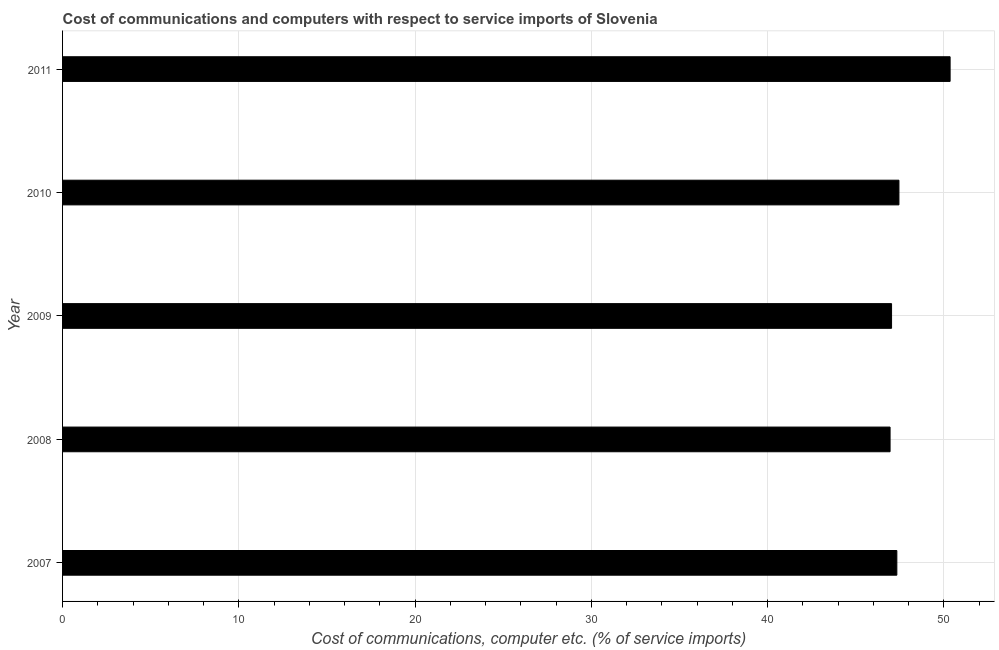Does the graph contain any zero values?
Keep it short and to the point. No. What is the title of the graph?
Ensure brevity in your answer.  Cost of communications and computers with respect to service imports of Slovenia. What is the label or title of the X-axis?
Provide a short and direct response. Cost of communications, computer etc. (% of service imports). What is the label or title of the Y-axis?
Ensure brevity in your answer.  Year. What is the cost of communications and computer in 2007?
Keep it short and to the point. 47.33. Across all years, what is the maximum cost of communications and computer?
Give a very brief answer. 50.35. Across all years, what is the minimum cost of communications and computer?
Keep it short and to the point. 46.95. In which year was the cost of communications and computer minimum?
Offer a very short reply. 2008. What is the sum of the cost of communications and computer?
Make the answer very short. 239.12. What is the difference between the cost of communications and computer in 2010 and 2011?
Provide a short and direct response. -2.9. What is the average cost of communications and computer per year?
Give a very brief answer. 47.82. What is the median cost of communications and computer?
Provide a succinct answer. 47.33. Do a majority of the years between 2009 and 2011 (inclusive) have cost of communications and computer greater than 42 %?
Make the answer very short. Yes. Is the cost of communications and computer in 2009 less than that in 2010?
Keep it short and to the point. Yes. Is the difference between the cost of communications and computer in 2010 and 2011 greater than the difference between any two years?
Provide a short and direct response. No. What is the difference between the highest and the second highest cost of communications and computer?
Offer a very short reply. 2.9. What is the difference between the highest and the lowest cost of communications and computer?
Ensure brevity in your answer.  3.41. How many bars are there?
Offer a very short reply. 5. What is the difference between two consecutive major ticks on the X-axis?
Keep it short and to the point. 10. What is the Cost of communications, computer etc. (% of service imports) of 2007?
Offer a terse response. 47.33. What is the Cost of communications, computer etc. (% of service imports) of 2008?
Give a very brief answer. 46.95. What is the Cost of communications, computer etc. (% of service imports) of 2009?
Offer a terse response. 47.03. What is the Cost of communications, computer etc. (% of service imports) of 2010?
Your answer should be very brief. 47.45. What is the Cost of communications, computer etc. (% of service imports) of 2011?
Provide a succinct answer. 50.35. What is the difference between the Cost of communications, computer etc. (% of service imports) in 2007 and 2008?
Your answer should be very brief. 0.38. What is the difference between the Cost of communications, computer etc. (% of service imports) in 2007 and 2009?
Offer a terse response. 0.3. What is the difference between the Cost of communications, computer etc. (% of service imports) in 2007 and 2010?
Ensure brevity in your answer.  -0.12. What is the difference between the Cost of communications, computer etc. (% of service imports) in 2007 and 2011?
Provide a short and direct response. -3.02. What is the difference between the Cost of communications, computer etc. (% of service imports) in 2008 and 2009?
Give a very brief answer. -0.08. What is the difference between the Cost of communications, computer etc. (% of service imports) in 2008 and 2010?
Ensure brevity in your answer.  -0.5. What is the difference between the Cost of communications, computer etc. (% of service imports) in 2008 and 2011?
Give a very brief answer. -3.41. What is the difference between the Cost of communications, computer etc. (% of service imports) in 2009 and 2010?
Make the answer very short. -0.42. What is the difference between the Cost of communications, computer etc. (% of service imports) in 2009 and 2011?
Give a very brief answer. -3.32. What is the difference between the Cost of communications, computer etc. (% of service imports) in 2010 and 2011?
Your response must be concise. -2.9. What is the ratio of the Cost of communications, computer etc. (% of service imports) in 2007 to that in 2008?
Offer a very short reply. 1.01. What is the ratio of the Cost of communications, computer etc. (% of service imports) in 2007 to that in 2009?
Provide a short and direct response. 1.01. What is the ratio of the Cost of communications, computer etc. (% of service imports) in 2007 to that in 2011?
Make the answer very short. 0.94. What is the ratio of the Cost of communications, computer etc. (% of service imports) in 2008 to that in 2010?
Keep it short and to the point. 0.99. What is the ratio of the Cost of communications, computer etc. (% of service imports) in 2008 to that in 2011?
Offer a terse response. 0.93. What is the ratio of the Cost of communications, computer etc. (% of service imports) in 2009 to that in 2010?
Keep it short and to the point. 0.99. What is the ratio of the Cost of communications, computer etc. (% of service imports) in 2009 to that in 2011?
Keep it short and to the point. 0.93. What is the ratio of the Cost of communications, computer etc. (% of service imports) in 2010 to that in 2011?
Provide a succinct answer. 0.94. 